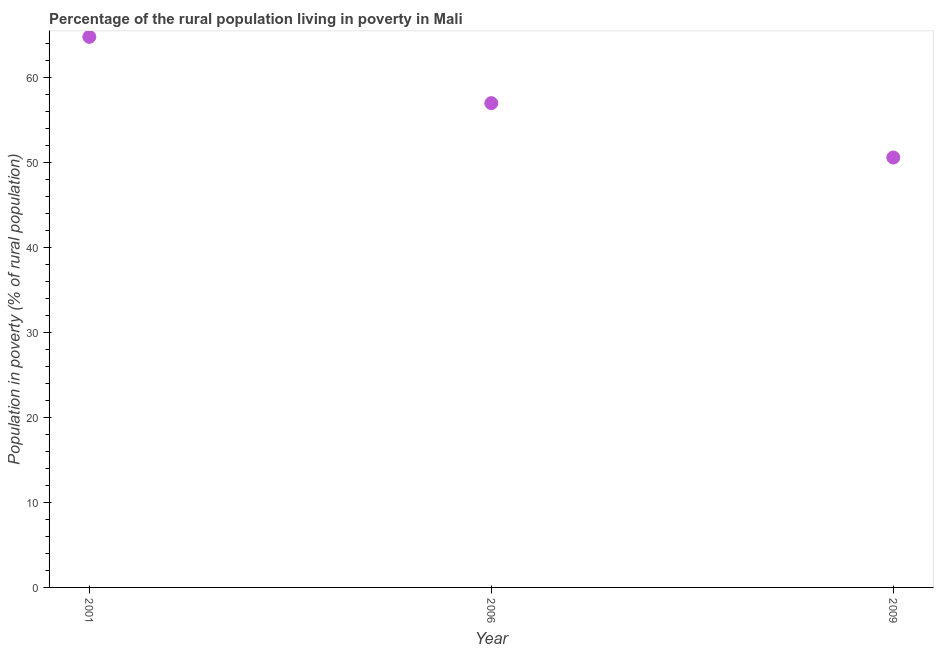Across all years, what is the maximum percentage of rural population living below poverty line?
Keep it short and to the point. 64.8. Across all years, what is the minimum percentage of rural population living below poverty line?
Your answer should be very brief. 50.6. In which year was the percentage of rural population living below poverty line maximum?
Keep it short and to the point. 2001. What is the sum of the percentage of rural population living below poverty line?
Ensure brevity in your answer.  172.4. What is the difference between the percentage of rural population living below poverty line in 2006 and 2009?
Your answer should be very brief. 6.4. What is the average percentage of rural population living below poverty line per year?
Offer a terse response. 57.47. In how many years, is the percentage of rural population living below poverty line greater than 12 %?
Offer a terse response. 3. What is the ratio of the percentage of rural population living below poverty line in 2001 to that in 2006?
Your answer should be compact. 1.14. What is the difference between the highest and the second highest percentage of rural population living below poverty line?
Your answer should be compact. 7.8. What is the difference between the highest and the lowest percentage of rural population living below poverty line?
Make the answer very short. 14.2. Does the percentage of rural population living below poverty line monotonically increase over the years?
Offer a very short reply. No. How many years are there in the graph?
Provide a succinct answer. 3. Are the values on the major ticks of Y-axis written in scientific E-notation?
Your answer should be very brief. No. What is the title of the graph?
Provide a short and direct response. Percentage of the rural population living in poverty in Mali. What is the label or title of the Y-axis?
Provide a succinct answer. Population in poverty (% of rural population). What is the Population in poverty (% of rural population) in 2001?
Offer a very short reply. 64.8. What is the Population in poverty (% of rural population) in 2009?
Give a very brief answer. 50.6. What is the difference between the Population in poverty (% of rural population) in 2001 and 2009?
Your response must be concise. 14.2. What is the difference between the Population in poverty (% of rural population) in 2006 and 2009?
Your answer should be very brief. 6.4. What is the ratio of the Population in poverty (% of rural population) in 2001 to that in 2006?
Your answer should be compact. 1.14. What is the ratio of the Population in poverty (% of rural population) in 2001 to that in 2009?
Make the answer very short. 1.28. What is the ratio of the Population in poverty (% of rural population) in 2006 to that in 2009?
Ensure brevity in your answer.  1.13. 